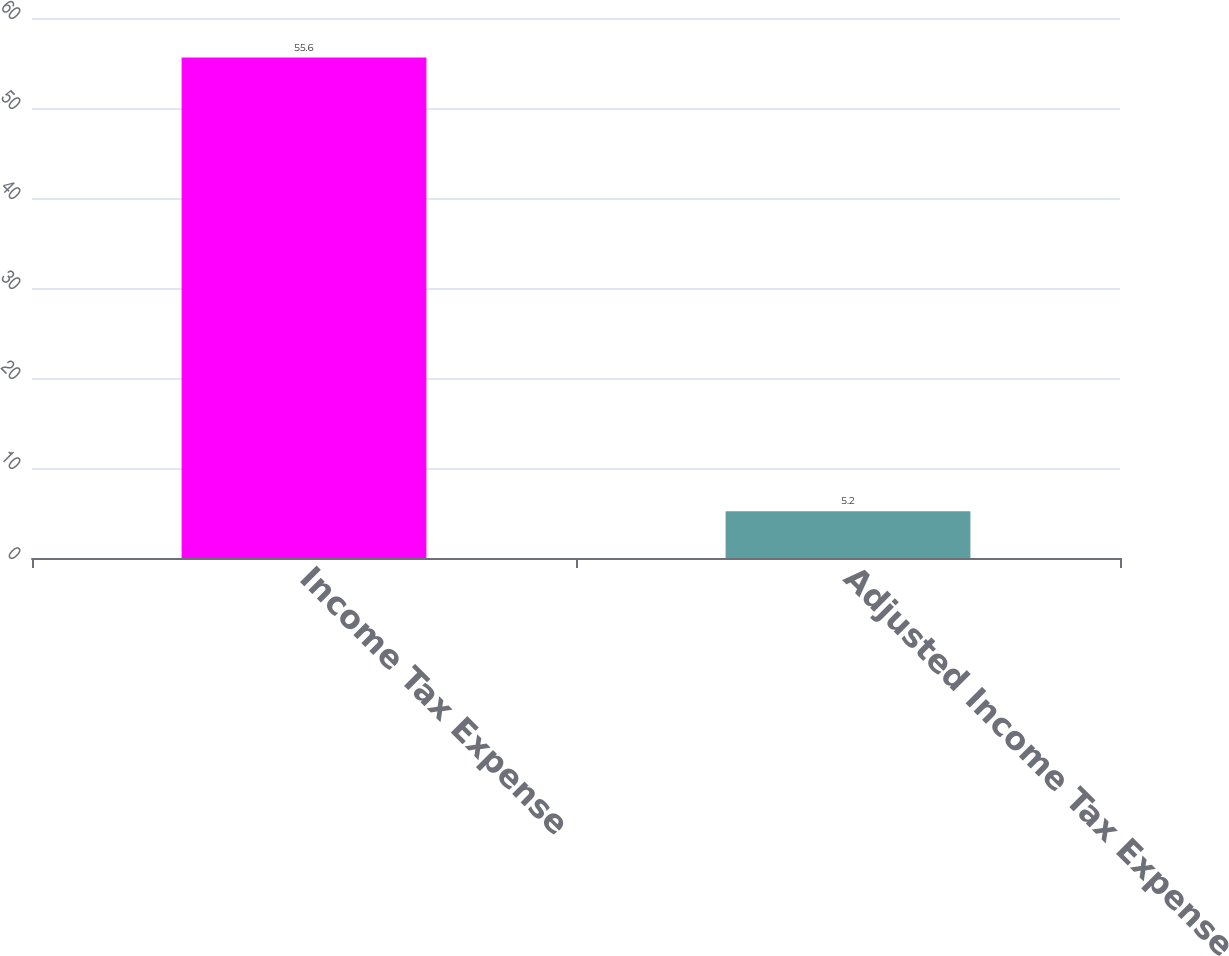Convert chart to OTSL. <chart><loc_0><loc_0><loc_500><loc_500><bar_chart><fcel>Income Tax Expense<fcel>Adjusted Income Tax Expense<nl><fcel>55.6<fcel>5.2<nl></chart> 